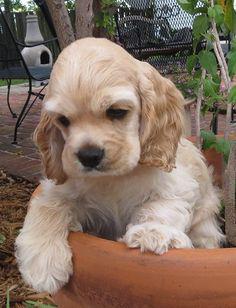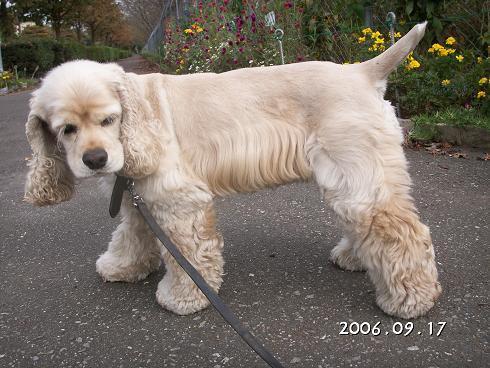The first image is the image on the left, the second image is the image on the right. Given the left and right images, does the statement "The left image contains at least three dogs." hold true? Answer yes or no. No. The first image is the image on the left, the second image is the image on the right. For the images displayed, is the sentence "The left image shows no less than three spaniel puppies, and the right image shows just one spaniel sitting" factually correct? Answer yes or no. No. 